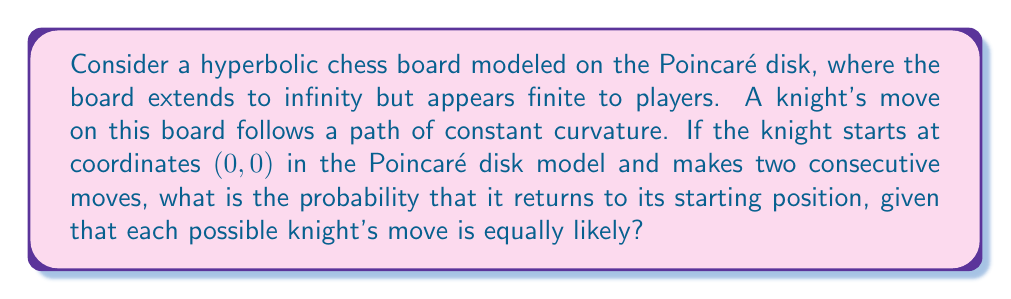Give your solution to this math problem. To solve this problem, we need to understand the geometry of the hyperbolic chess board and the knight's movement on it:

1) In the Poincaré disk model, the board is represented by the interior of a unit circle. Straight lines in hyperbolic geometry are represented by arcs of circles that intersect the boundary circle at right angles.

2) A knight's move on this board would follow a path of constant curvature, which in the Poincaré disk model would look like an arc of a circle.

3) From the starting position $(0, 0)$, the knight has 8 possible moves, just like on a regular chess board. Due to the symmetry of the Poincaré disk, these moves would form a regular octagon around the origin.

4) After the first move, the knight would be at one of these 8 positions. From each of these positions, it again has 8 possible moves.

5) To return to the starting position after two moves, the knight must make two moves that cancel each other out. This is only possible if the second move is the exact opposite of the first move.

6) Out of the 8 possible second moves, only 1 will bring the knight back to the starting position.

7) The probability of returning to the starting position after two moves is thus:

   $$P(\text{return}) = 1 \cdot \frac{1}{8} = \frac{1}{8}$$

   This is because the probability of making any specific first move is 1 (as we know the knight moved), and the probability of making the exact opposite move on the second turn is $\frac{1}{8}$.
Answer: $\frac{1}{8}$ 